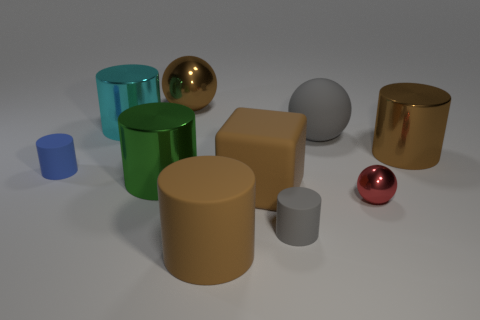Are there the same number of brown cubes that are in front of the tiny metallic sphere and brown things on the right side of the cyan metallic thing?
Keep it short and to the point. No. Are there any cylinders made of the same material as the small ball?
Your answer should be very brief. Yes. Does the tiny cylinder that is on the right side of the cyan metal object have the same material as the large brown cube?
Offer a terse response. Yes. There is a brown object that is both in front of the brown sphere and behind the big brown block; how big is it?
Make the answer very short. Large. The large metallic ball is what color?
Ensure brevity in your answer.  Brown. How many large yellow rubber objects are there?
Provide a short and direct response. 0. What number of small metal balls have the same color as the large rubber cylinder?
Your answer should be compact. 0. Is the shape of the large brown thing that is behind the brown shiny cylinder the same as the gray matte object that is on the left side of the gray ball?
Provide a succinct answer. No. There is a big block that is in front of the big sphere that is to the right of the brown metal object that is to the left of the red metallic sphere; what is its color?
Your answer should be very brief. Brown. There is a small matte cylinder behind the green cylinder; what color is it?
Offer a terse response. Blue. 